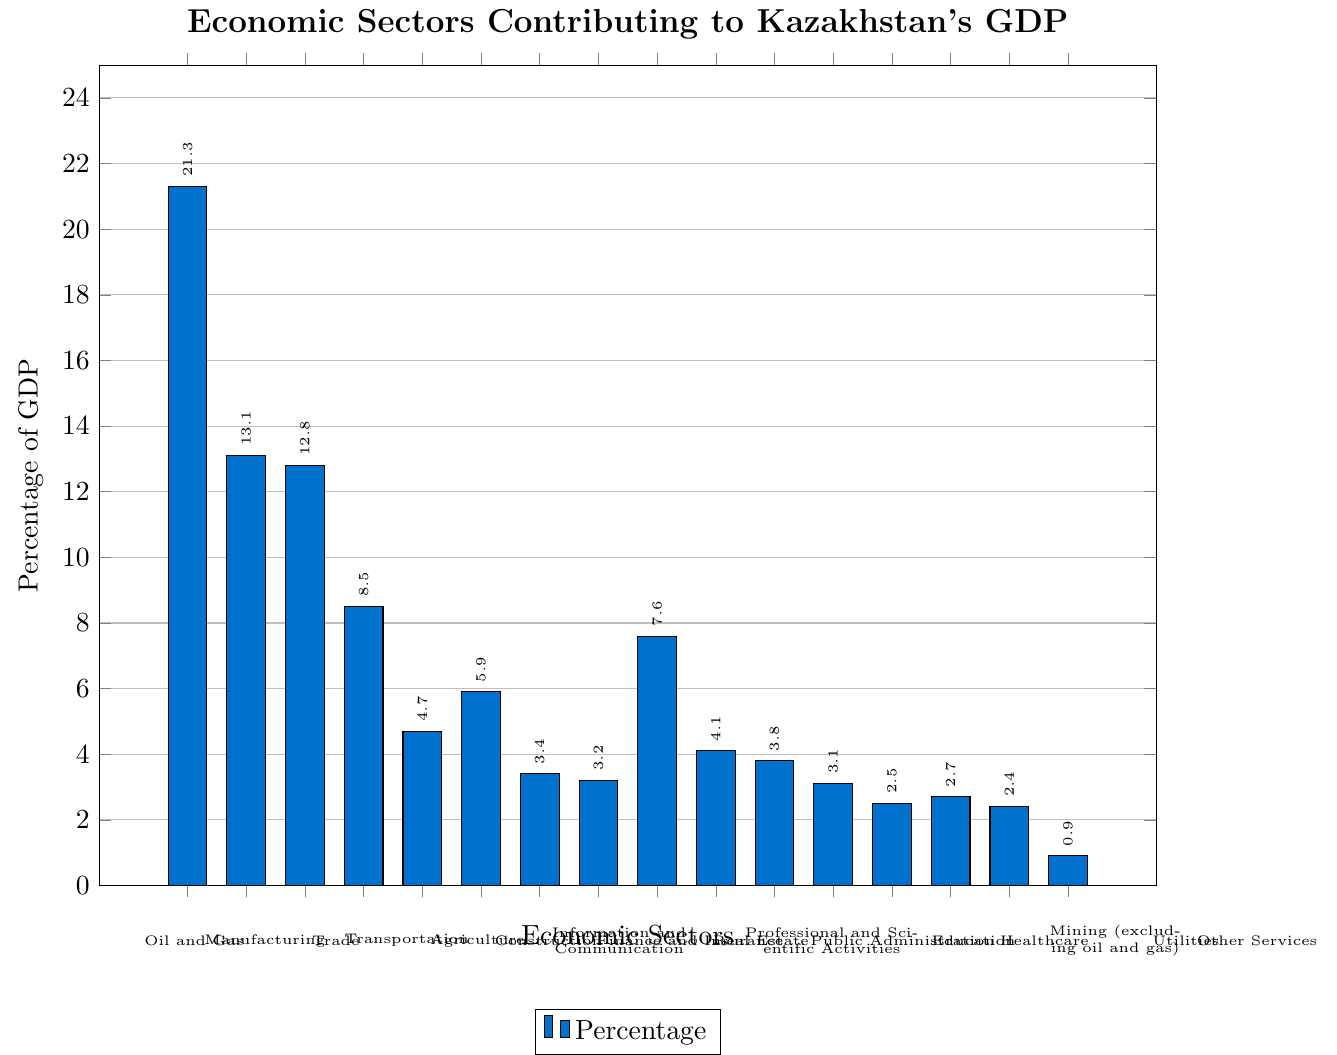What sector contributes the most to Kazakhstan's GDP? The bar for the "Oil and Gas" sector is the tallest in the figure, indicating it has the highest percentage.
Answer: Oil and Gas Which sector contributes more to the GDP: Manufacturing or Trade? The figure shows that the "Manufacturing" sector contributes 13.1%, while the "Trade" sector contributes 12.8%. Since 13.1% is greater than 12.8%, Manufacturing contributes more.
Answer: Manufacturing What is the combined contribution of the Oil and Gas and Real Estate sectors to the GDP? The contribution of the "Oil and Gas" sector is 21.3% and the "Real Estate" sector is 7.6%. Summing these gives 21.3 + 7.6 = 28.9%.
Answer: 28.9% How much greater is the contribution of the Transportation sector compared to the Utilities sector? The figure shows that "Transportation" contributes 8.5% and "Utilities" contributes 2.4%. The difference is 8.5 - 2.4 = 6.1%.
Answer: 6.1% Which two sectors have the closest contributions to Kazakhstan's GDP? The "Manufacturing" sector contributes 13.1% and "Trade" contributes 12.8%. The difference between their contributions is the smallest among all pairs of sectors.
Answer: Manufacturing and Trade What is the average percentage contribution of the Public Administration, Education, and Healthcare sectors? Their contributions are 3.8%, 3.1%, and 2.5% respectively. The average is calculated as (3.8 + 3.1 + 2.5) / 3 = 9.4 / 3 ≈ 3.13%.
Answer: 3.13% Which sector has the smallest contribution to Kazakhstan's GDP? The figure shows the shortest bar for the "Other Services" sector, indicating it has the smallest contribution of 0.9%.
Answer: Other Services Is the contribution of the Agriculture sector more or less than 5%? The figure shows that the "Agriculture" sector contributes 4.7%, which is less than 5%.
Answer: Less What is the total percentage contribution of all sectors related to services (Trade, Real Estate, Finance and Insurance, Professional and Scientific Activities, Public Administration, Education, Healthcare, Other Services)? Summing their contributions: 12.8 (Trade) + 7.6 (Real Estate) + 3.2 (Finance and Insurance) + 4.1 (Professional and Scientific Activities) + 3.8 (Public Administration) + 3.1 (Education) + 2.5 (Healthcare) + 0.9 (Other Services) = 38%.
Answer: 38% How does the contribution of the Manufacturing sector compare to the combined contributions of the Utilities and Mining (excluding oil and gas) sectors? The "Manufacturing" sector contributes 13.1%, while "Utilities" and "Mining (excluding oil and gas)" contribute 2.4% + 2.7% = 5.1%. Since 13.1% is greater than 5.1%, Manufacturing contributes more.
Answer: Manufacturing contributes more 